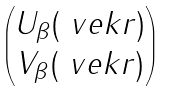<formula> <loc_0><loc_0><loc_500><loc_500>\begin{pmatrix} U _ { \beta } ( \ v e k { r } ) \\ V _ { \beta } ( \ v e k { r } ) \end{pmatrix}</formula> 